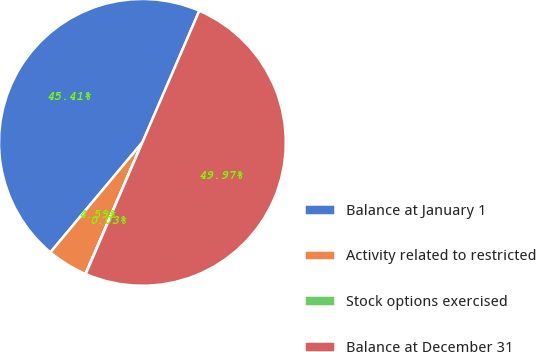Convert chart. <chart><loc_0><loc_0><loc_500><loc_500><pie_chart><fcel>Balance at January 1<fcel>Activity related to restricted<fcel>Stock options exercised<fcel>Balance at December 31<nl><fcel>45.41%<fcel>4.59%<fcel>0.03%<fcel>49.97%<nl></chart> 